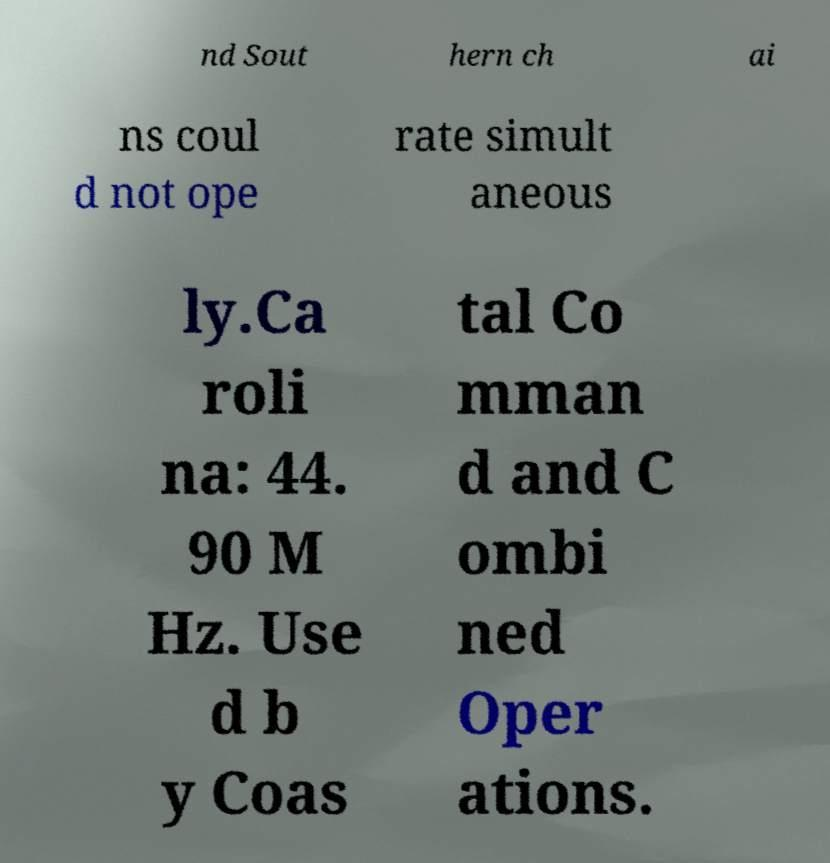Could you extract and type out the text from this image? nd Sout hern ch ai ns coul d not ope rate simult aneous ly.Ca roli na: 44. 90 M Hz. Use d b y Coas tal Co mman d and C ombi ned Oper ations. 